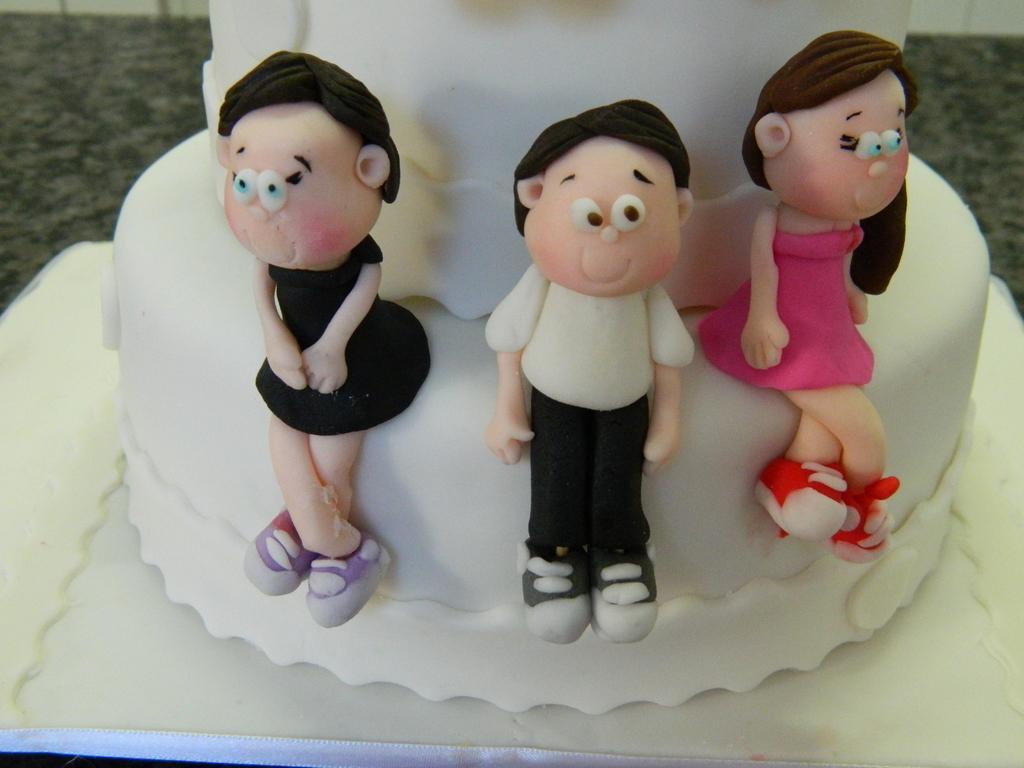How would you summarize this image in a sentence or two? These three toys are placed on this white cake. This cake is kept on this white surface. Background it is blur. 